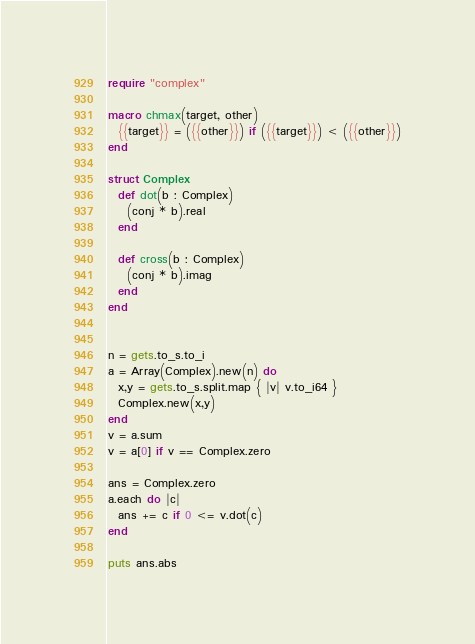Convert code to text. <code><loc_0><loc_0><loc_500><loc_500><_Crystal_>require "complex"

macro chmax(target, other)
  {{target}} = ({{other}}) if ({{target}}) < ({{other}})
end

struct Complex
  def dot(b : Complex)
    (conj * b).real
  end

  def cross(b : Complex)
    (conj * b).imag
  end
end


n = gets.to_s.to_i
a = Array(Complex).new(n) do
  x,y = gets.to_s.split.map { |v| v.to_i64 }
  Complex.new(x,y)
end
v = a.sum
v = a[0] if v == Complex.zero

ans = Complex.zero
a.each do |c|
  ans += c if 0 <= v.dot(c)
end

puts ans.abs

</code> 